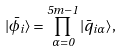Convert formula to latex. <formula><loc_0><loc_0><loc_500><loc_500>| \bar { \phi _ { i } } \rangle = \prod _ { \alpha = 0 } ^ { 5 m - 1 } | \bar { q } _ { i \alpha } \rangle ,</formula> 